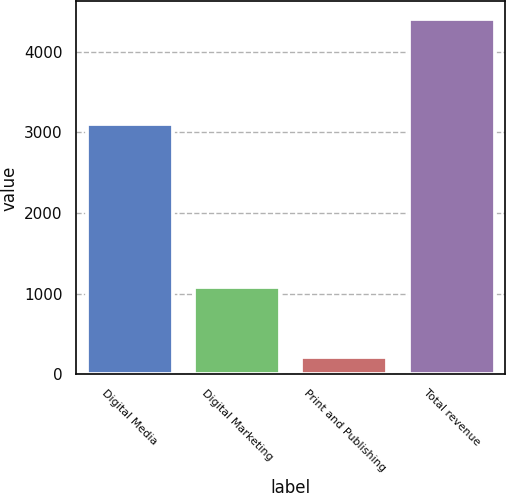Convert chart. <chart><loc_0><loc_0><loc_500><loc_500><bar_chart><fcel>Digital Media<fcel>Digital Marketing<fcel>Print and Publishing<fcel>Total revenue<nl><fcel>3101.9<fcel>1085<fcel>216.8<fcel>4403.7<nl></chart> 